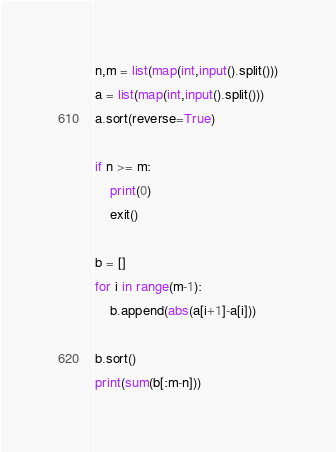<code> <loc_0><loc_0><loc_500><loc_500><_Python_>n,m = list(map(int,input().split()))
a = list(map(int,input().split()))
a.sort(reverse=True)

if n >= m:
    print(0)
    exit()

b = []
for i in range(m-1):
    b.append(abs(a[i+1]-a[i]))

b.sort()
print(sum(b[:m-n]))</code> 